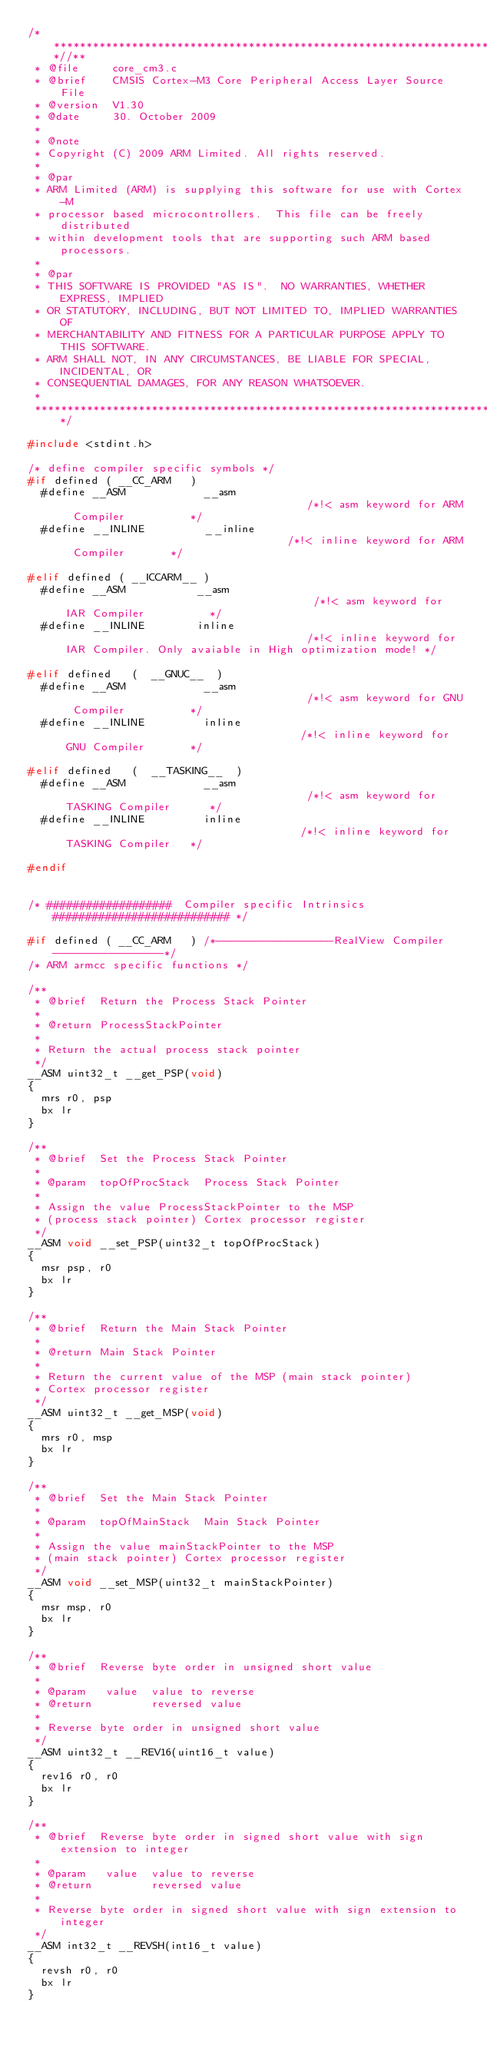Convert code to text. <code><loc_0><loc_0><loc_500><loc_500><_C_>/**************************************************************************//**
 * @file     core_cm3.c
 * @brief    CMSIS Cortex-M3 Core Peripheral Access Layer Source File
 * @version  V1.30
 * @date     30. October 2009
 *
 * @note
 * Copyright (C) 2009 ARM Limited. All rights reserved.
 *
 * @par
 * ARM Limited (ARM) is supplying this software for use with Cortex-M 
 * processor based microcontrollers.  This file can be freely distributed 
 * within development tools that are supporting such ARM based processors. 
 *
 * @par
 * THIS SOFTWARE IS PROVIDED "AS IS".  NO WARRANTIES, WHETHER EXPRESS, IMPLIED
 * OR STATUTORY, INCLUDING, BUT NOT LIMITED TO, IMPLIED WARRANTIES OF
 * MERCHANTABILITY AND FITNESS FOR A PARTICULAR PURPOSE APPLY TO THIS SOFTWARE.
 * ARM SHALL NOT, IN ANY CIRCUMSTANCES, BE LIABLE FOR SPECIAL, INCIDENTAL, OR
 * CONSEQUENTIAL DAMAGES, FOR ANY REASON WHATSOEVER.
 *
 ******************************************************************************/

#include <stdint.h>

/* define compiler specific symbols */
#if defined ( __CC_ARM   )
  #define __ASM            __asm                                      /*!< asm keyword for ARM Compiler          */
  #define __INLINE         __inline                                   /*!< inline keyword for ARM Compiler       */

#elif defined ( __ICCARM__ )
  #define __ASM           __asm                                       /*!< asm keyword for IAR Compiler          */
  #define __INLINE        inline                                      /*!< inline keyword for IAR Compiler. Only avaiable in High optimization mode! */

#elif defined   (  __GNUC__  )
  #define __ASM            __asm                                      /*!< asm keyword for GNU Compiler          */
  #define __INLINE         inline                                     /*!< inline keyword for GNU Compiler       */

#elif defined   (  __TASKING__  )
  #define __ASM            __asm                                      /*!< asm keyword for TASKING Compiler      */
  #define __INLINE         inline                                     /*!< inline keyword for TASKING Compiler   */

#endif


/* ###################  Compiler specific Intrinsics  ########################### */

#if defined ( __CC_ARM   ) /*------------------RealView Compiler -----------------*/
/* ARM armcc specific functions */

/**
 * @brief  Return the Process Stack Pointer
 *
 * @return ProcessStackPointer
 *
 * Return the actual process stack pointer
 */
__ASM uint32_t __get_PSP(void)
{
  mrs r0, psp
  bx lr
}

/**
 * @brief  Set the Process Stack Pointer
 *
 * @param  topOfProcStack  Process Stack Pointer
 *
 * Assign the value ProcessStackPointer to the MSP 
 * (process stack pointer) Cortex processor register
 */
__ASM void __set_PSP(uint32_t topOfProcStack)
{
  msr psp, r0
  bx lr
}

/**
 * @brief  Return the Main Stack Pointer
 *
 * @return Main Stack Pointer
 *
 * Return the current value of the MSP (main stack pointer)
 * Cortex processor register
 */
__ASM uint32_t __get_MSP(void)
{
  mrs r0, msp
  bx lr
}

/**
 * @brief  Set the Main Stack Pointer
 *
 * @param  topOfMainStack  Main Stack Pointer
 *
 * Assign the value mainStackPointer to the MSP 
 * (main stack pointer) Cortex processor register
 */
__ASM void __set_MSP(uint32_t mainStackPointer)
{
  msr msp, r0
  bx lr
}

/**
 * @brief  Reverse byte order in unsigned short value
 *
 * @param   value  value to reverse
 * @return         reversed value
 *
 * Reverse byte order in unsigned short value
 */
__ASM uint32_t __REV16(uint16_t value)
{
  rev16 r0, r0
  bx lr
}

/**
 * @brief  Reverse byte order in signed short value with sign extension to integer
 *
 * @param   value  value to reverse
 * @return         reversed value
 *
 * Reverse byte order in signed short value with sign extension to integer
 */
__ASM int32_t __REVSH(int16_t value)
{
  revsh r0, r0
  bx lr
}

</code> 